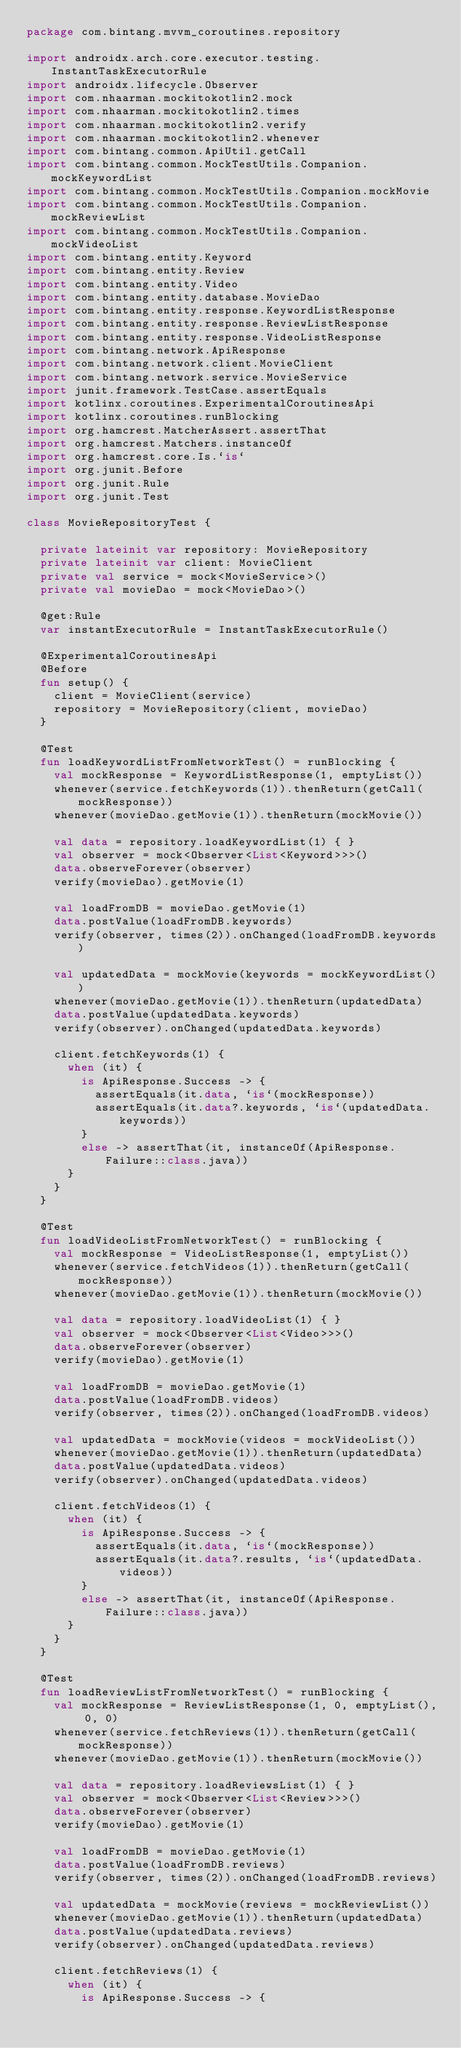Convert code to text. <code><loc_0><loc_0><loc_500><loc_500><_Kotlin_>package com.bintang.mvvm_coroutines.repository

import androidx.arch.core.executor.testing.InstantTaskExecutorRule
import androidx.lifecycle.Observer
import com.nhaarman.mockitokotlin2.mock
import com.nhaarman.mockitokotlin2.times
import com.nhaarman.mockitokotlin2.verify
import com.nhaarman.mockitokotlin2.whenever
import com.bintang.common.ApiUtil.getCall
import com.bintang.common.MockTestUtils.Companion.mockKeywordList
import com.bintang.common.MockTestUtils.Companion.mockMovie
import com.bintang.common.MockTestUtils.Companion.mockReviewList
import com.bintang.common.MockTestUtils.Companion.mockVideoList
import com.bintang.entity.Keyword
import com.bintang.entity.Review
import com.bintang.entity.Video
import com.bintang.entity.database.MovieDao
import com.bintang.entity.response.KeywordListResponse
import com.bintang.entity.response.ReviewListResponse
import com.bintang.entity.response.VideoListResponse
import com.bintang.network.ApiResponse
import com.bintang.network.client.MovieClient
import com.bintang.network.service.MovieService
import junit.framework.TestCase.assertEquals
import kotlinx.coroutines.ExperimentalCoroutinesApi
import kotlinx.coroutines.runBlocking
import org.hamcrest.MatcherAssert.assertThat
import org.hamcrest.Matchers.instanceOf
import org.hamcrest.core.Is.`is`
import org.junit.Before
import org.junit.Rule
import org.junit.Test

class MovieRepositoryTest {

  private lateinit var repository: MovieRepository
  private lateinit var client: MovieClient
  private val service = mock<MovieService>()
  private val movieDao = mock<MovieDao>()

  @get:Rule
  var instantExecutorRule = InstantTaskExecutorRule()

  @ExperimentalCoroutinesApi
  @Before
  fun setup() {
    client = MovieClient(service)
    repository = MovieRepository(client, movieDao)
  }

  @Test
  fun loadKeywordListFromNetworkTest() = runBlocking {
    val mockResponse = KeywordListResponse(1, emptyList())
    whenever(service.fetchKeywords(1)).thenReturn(getCall(mockResponse))
    whenever(movieDao.getMovie(1)).thenReturn(mockMovie())

    val data = repository.loadKeywordList(1) { }
    val observer = mock<Observer<List<Keyword>>>()
    data.observeForever(observer)
    verify(movieDao).getMovie(1)

    val loadFromDB = movieDao.getMovie(1)
    data.postValue(loadFromDB.keywords)
    verify(observer, times(2)).onChanged(loadFromDB.keywords)

    val updatedData = mockMovie(keywords = mockKeywordList())
    whenever(movieDao.getMovie(1)).thenReturn(updatedData)
    data.postValue(updatedData.keywords)
    verify(observer).onChanged(updatedData.keywords)

    client.fetchKeywords(1) {
      when (it) {
        is ApiResponse.Success -> {
          assertEquals(it.data, `is`(mockResponse))
          assertEquals(it.data?.keywords, `is`(updatedData.keywords))
        }
        else -> assertThat(it, instanceOf(ApiResponse.Failure::class.java))
      }
    }
  }

  @Test
  fun loadVideoListFromNetworkTest() = runBlocking {
    val mockResponse = VideoListResponse(1, emptyList())
    whenever(service.fetchVideos(1)).thenReturn(getCall(mockResponse))
    whenever(movieDao.getMovie(1)).thenReturn(mockMovie())

    val data = repository.loadVideoList(1) { }
    val observer = mock<Observer<List<Video>>>()
    data.observeForever(observer)
    verify(movieDao).getMovie(1)

    val loadFromDB = movieDao.getMovie(1)
    data.postValue(loadFromDB.videos)
    verify(observer, times(2)).onChanged(loadFromDB.videos)

    val updatedData = mockMovie(videos = mockVideoList())
    whenever(movieDao.getMovie(1)).thenReturn(updatedData)
    data.postValue(updatedData.videos)
    verify(observer).onChanged(updatedData.videos)

    client.fetchVideos(1) {
      when (it) {
        is ApiResponse.Success -> {
          assertEquals(it.data, `is`(mockResponse))
          assertEquals(it.data?.results, `is`(updatedData.videos))
        }
        else -> assertThat(it, instanceOf(ApiResponse.Failure::class.java))
      }
    }
  }

  @Test
  fun loadReviewListFromNetworkTest() = runBlocking {
    val mockResponse = ReviewListResponse(1, 0, emptyList(), 0, 0)
    whenever(service.fetchReviews(1)).thenReturn(getCall(mockResponse))
    whenever(movieDao.getMovie(1)).thenReturn(mockMovie())

    val data = repository.loadReviewsList(1) { }
    val observer = mock<Observer<List<Review>>>()
    data.observeForever(observer)
    verify(movieDao).getMovie(1)

    val loadFromDB = movieDao.getMovie(1)
    data.postValue(loadFromDB.reviews)
    verify(observer, times(2)).onChanged(loadFromDB.reviews)

    val updatedData = mockMovie(reviews = mockReviewList())
    whenever(movieDao.getMovie(1)).thenReturn(updatedData)
    data.postValue(updatedData.reviews)
    verify(observer).onChanged(updatedData.reviews)

    client.fetchReviews(1) {
      when (it) {
        is ApiResponse.Success -> {</code> 